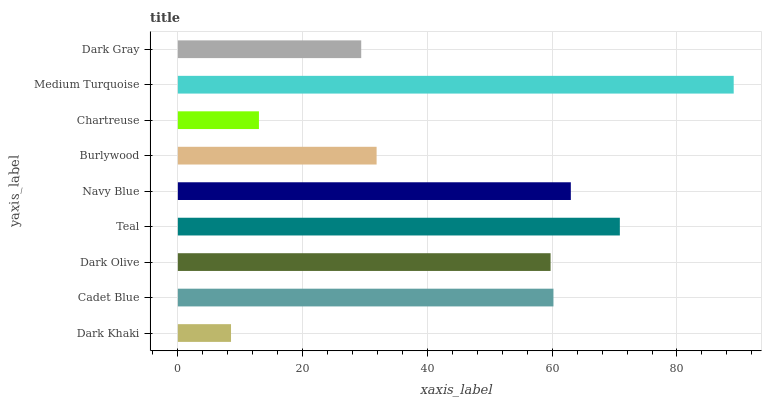Is Dark Khaki the minimum?
Answer yes or no. Yes. Is Medium Turquoise the maximum?
Answer yes or no. Yes. Is Cadet Blue the minimum?
Answer yes or no. No. Is Cadet Blue the maximum?
Answer yes or no. No. Is Cadet Blue greater than Dark Khaki?
Answer yes or no. Yes. Is Dark Khaki less than Cadet Blue?
Answer yes or no. Yes. Is Dark Khaki greater than Cadet Blue?
Answer yes or no. No. Is Cadet Blue less than Dark Khaki?
Answer yes or no. No. Is Dark Olive the high median?
Answer yes or no. Yes. Is Dark Olive the low median?
Answer yes or no. Yes. Is Teal the high median?
Answer yes or no. No. Is Burlywood the low median?
Answer yes or no. No. 